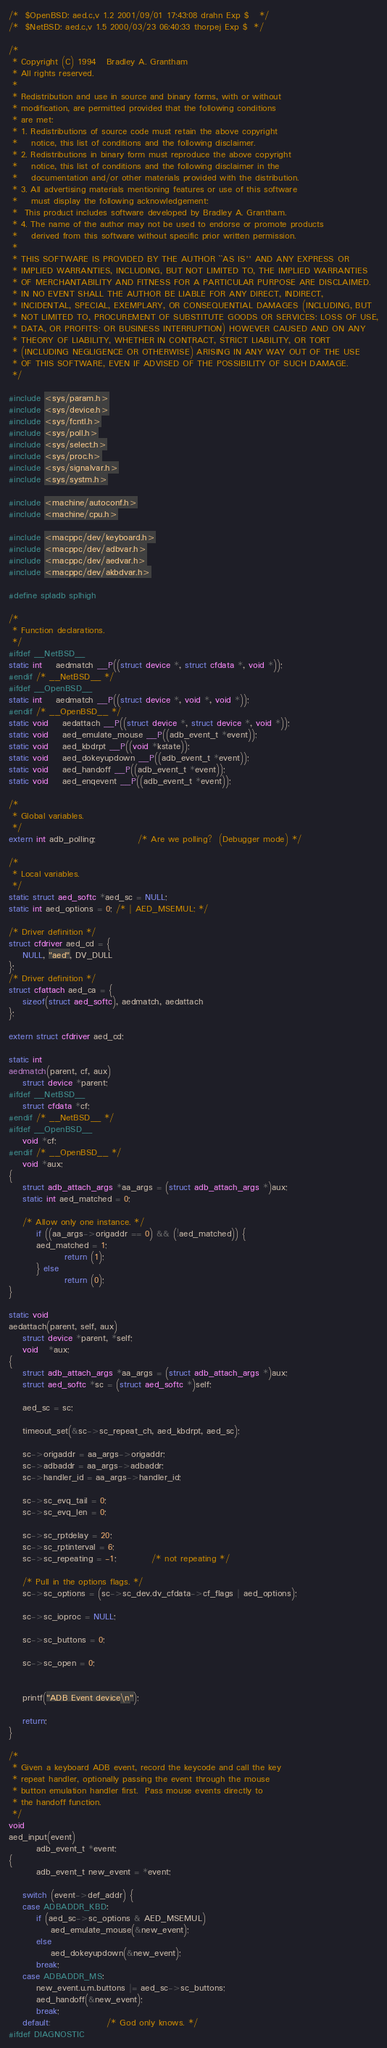Convert code to text. <code><loc_0><loc_0><loc_500><loc_500><_C_>/*	$OpenBSD: aed.c,v 1.2 2001/09/01 17:43:08 drahn Exp $	*/
/*	$NetBSD: aed.c,v 1.5 2000/03/23 06:40:33 thorpej Exp $	*/

/*
 * Copyright (C) 1994	Bradley A. Grantham
 * All rights reserved.
 *
 * Redistribution and use in source and binary forms, with or without
 * modification, are permitted provided that the following conditions
 * are met:
 * 1. Redistributions of source code must retain the above copyright
 *    notice, this list of conditions and the following disclaimer.
 * 2. Redistributions in binary form must reproduce the above copyright
 *    notice, this list of conditions and the following disclaimer in the
 *    documentation and/or other materials provided with the distribution.
 * 3. All advertising materials mentioning features or use of this software
 *    must display the following acknowledgement:
 *	This product includes software developed by Bradley A. Grantham.
 * 4. The name of the author may not be used to endorse or promote products
 *    derived from this software without specific prior written permission.
 *
 * THIS SOFTWARE IS PROVIDED BY THE AUTHOR ``AS IS'' AND ANY EXPRESS OR
 * IMPLIED WARRANTIES, INCLUDING, BUT NOT LIMITED TO, THE IMPLIED WARRANTIES
 * OF MERCHANTABILITY AND FITNESS FOR A PARTICULAR PURPOSE ARE DISCLAIMED.
 * IN NO EVENT SHALL THE AUTHOR BE LIABLE FOR ANY DIRECT, INDIRECT,
 * INCIDENTAL, SPECIAL, EXEMPLARY, OR CONSEQUENTIAL DAMAGES (INCLUDING, BUT
 * NOT LIMITED TO, PROCUREMENT OF SUBSTITUTE GOODS OR SERVICES; LOSS OF USE,
 * DATA, OR PROFITS; OR BUSINESS INTERRUPTION) HOWEVER CAUSED AND ON ANY
 * THEORY OF LIABILITY, WHETHER IN CONTRACT, STRICT LIABILITY, OR TORT
 * (INCLUDING NEGLIGENCE OR OTHERWISE) ARISING IN ANY WAY OUT OF THE USE
 * OF THIS SOFTWARE, EVEN IF ADVISED OF THE POSSIBILITY OF SUCH DAMAGE.
 */

#include <sys/param.h>
#include <sys/device.h>
#include <sys/fcntl.h>
#include <sys/poll.h>
#include <sys/select.h>
#include <sys/proc.h>
#include <sys/signalvar.h>
#include <sys/systm.h>

#include <machine/autoconf.h>
#include <machine/cpu.h>

#include <macppc/dev/keyboard.h>
#include <macppc/dev/adbvar.h>
#include <macppc/dev/aedvar.h>
#include <macppc/dev/akbdvar.h>

#define spladb splhigh

/*
 * Function declarations.
 */
#ifdef __NetBSD__
static int	aedmatch __P((struct device *, struct cfdata *, void *));
#endif /* __NetBSD__ */
#ifdef __OpenBSD__
static int	aedmatch __P((struct device *, void *, void *));
#endif /* __OpenBSD__ */
static void	aedattach __P((struct device *, struct device *, void *));
static void	aed_emulate_mouse __P((adb_event_t *event));
static void	aed_kbdrpt __P((void *kstate));
static void	aed_dokeyupdown __P((adb_event_t *event));
static void	aed_handoff __P((adb_event_t *event));
static void	aed_enqevent __P((adb_event_t *event));

/*
 * Global variables.
 */
extern int adb_polling;			/* Are we polling?  (Debugger mode) */

/*
 * Local variables.
 */
static struct aed_softc *aed_sc = NULL;
static int aed_options = 0; /* | AED_MSEMUL; */

/* Driver definition */
struct cfdriver aed_cd = {
	NULL, "aed", DV_DULL
};
/* Driver definition */
struct cfattach aed_ca = {
	sizeof(struct aed_softc), aedmatch, aedattach
};

extern struct cfdriver aed_cd;

static int
aedmatch(parent, cf, aux)
	struct device *parent;
#ifdef __NetBSD__
	struct cfdata *cf;
#endif /* __NetBSD__ */
#ifdef __OpenBSD__
	void *cf;
#endif /* __OpenBSD__ */
	void *aux;
{
	struct adb_attach_args *aa_args = (struct adb_attach_args *)aux;
	static int aed_matched = 0;

	/* Allow only one instance. */
        if ((aa_args->origaddr == 0) && (!aed_matched)) {
		aed_matched = 1;
                return (1);
        } else
                return (0);
}

static void
aedattach(parent, self, aux)
	struct device *parent, *self;
	void   *aux;
{
	struct adb_attach_args *aa_args = (struct adb_attach_args *)aux;
	struct aed_softc *sc = (struct aed_softc *)self;

	aed_sc = sc;

	timeout_set(&sc->sc_repeat_ch, aed_kbdrpt, aed_sc);

	sc->origaddr = aa_args->origaddr;
	sc->adbaddr = aa_args->adbaddr;
	sc->handler_id = aa_args->handler_id;

	sc->sc_evq_tail = 0;
	sc->sc_evq_len = 0;

	sc->sc_rptdelay = 20;
	sc->sc_rptinterval = 6;
	sc->sc_repeating = -1;          /* not repeating */

	/* Pull in the options flags. */ 
	sc->sc_options = (sc->sc_dev.dv_cfdata->cf_flags | aed_options);

	sc->sc_ioproc = NULL;
	
	sc->sc_buttons = 0;

	sc->sc_open = 0;


	printf("ADB Event device\n");

	return;
}

/*
 * Given a keyboard ADB event, record the keycode and call the key 
 * repeat handler, optionally passing the event through the mouse
 * button emulation handler first.  Pass mouse events directly to
 * the handoff function.
 */
void
aed_input(event)
        adb_event_t *event;
{
        adb_event_t new_event = *event;

	switch (event->def_addr) {
	case ADBADDR_KBD:
		if (aed_sc->sc_options & AED_MSEMUL)
			aed_emulate_mouse(&new_event);
		else
			aed_dokeyupdown(&new_event);
		break;
	case ADBADDR_MS:
		new_event.u.m.buttons |= aed_sc->sc_buttons;
		aed_handoff(&new_event);
		break;
	default:                /* God only knows. */
#ifdef DIAGNOSTIC</code> 